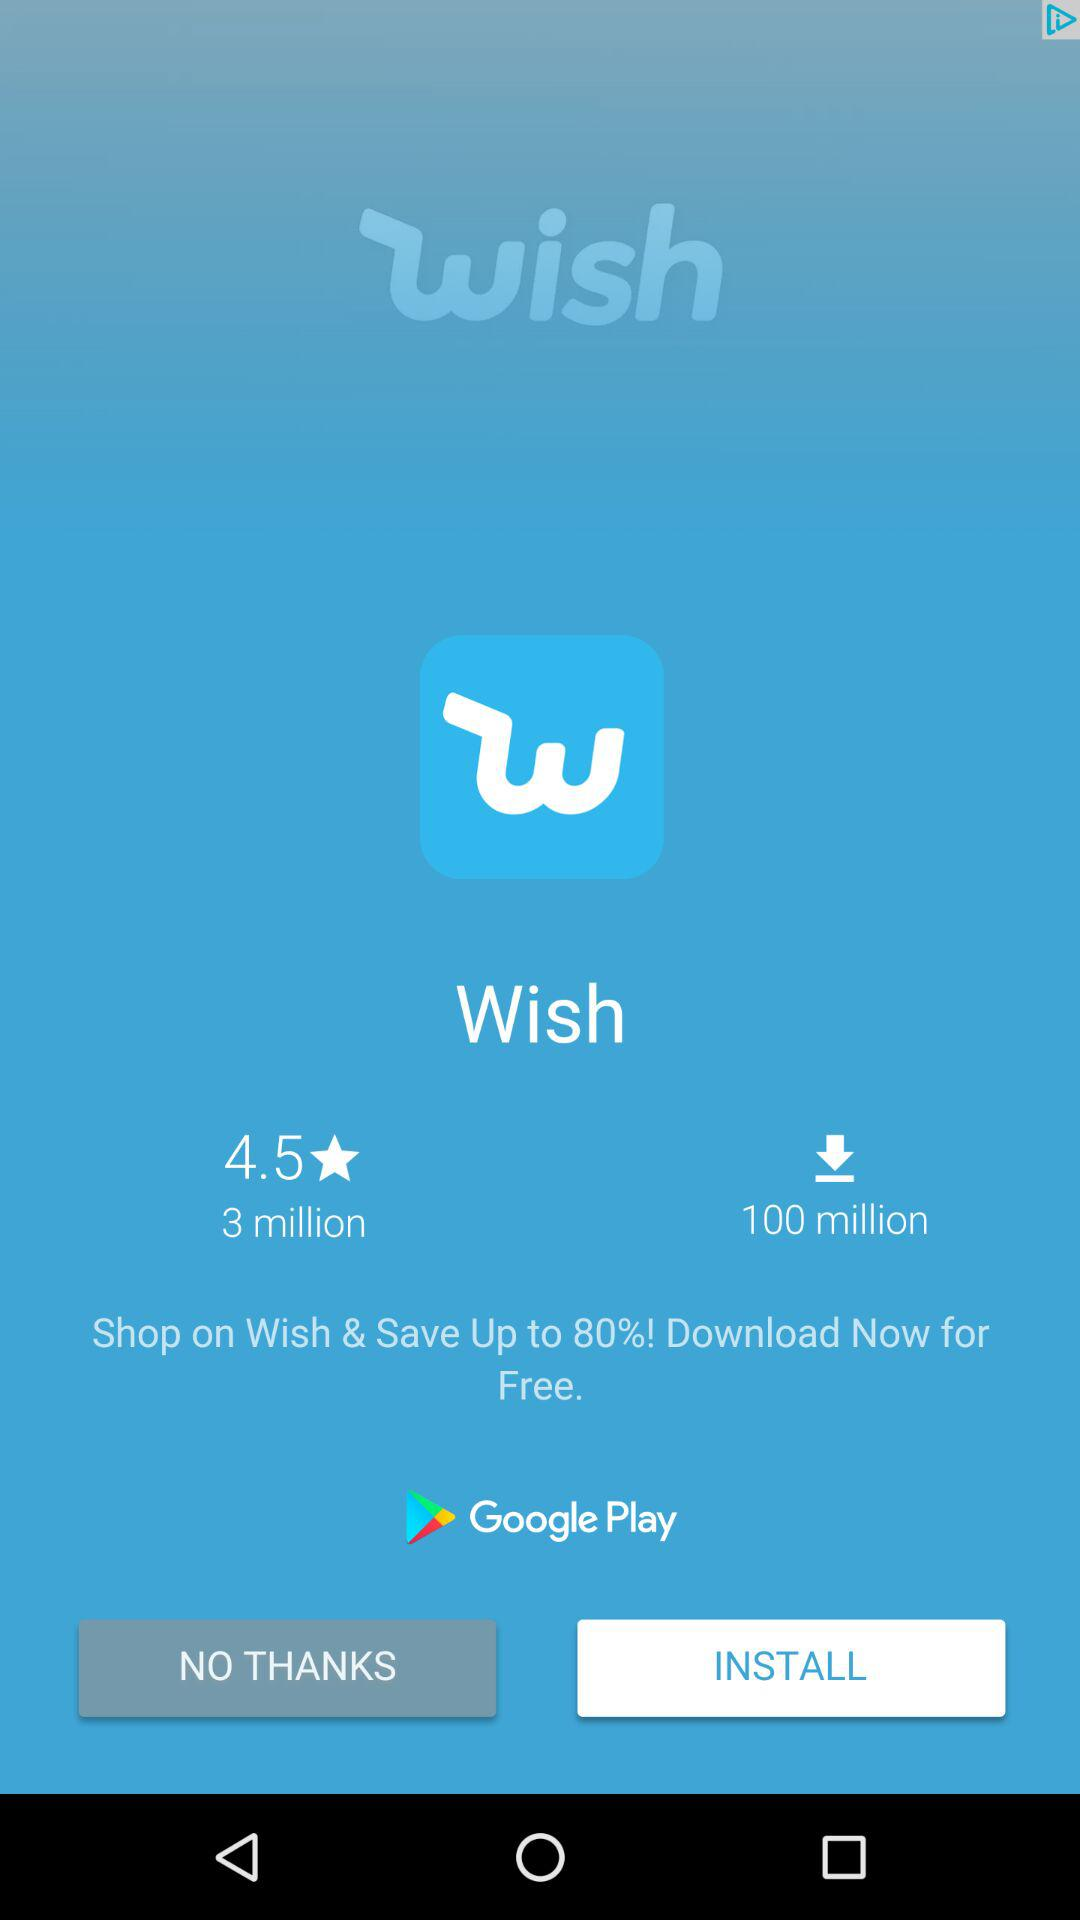How many more downloads does the app have than the number of people who have rated it?
Answer the question using a single word or phrase. 97 million 